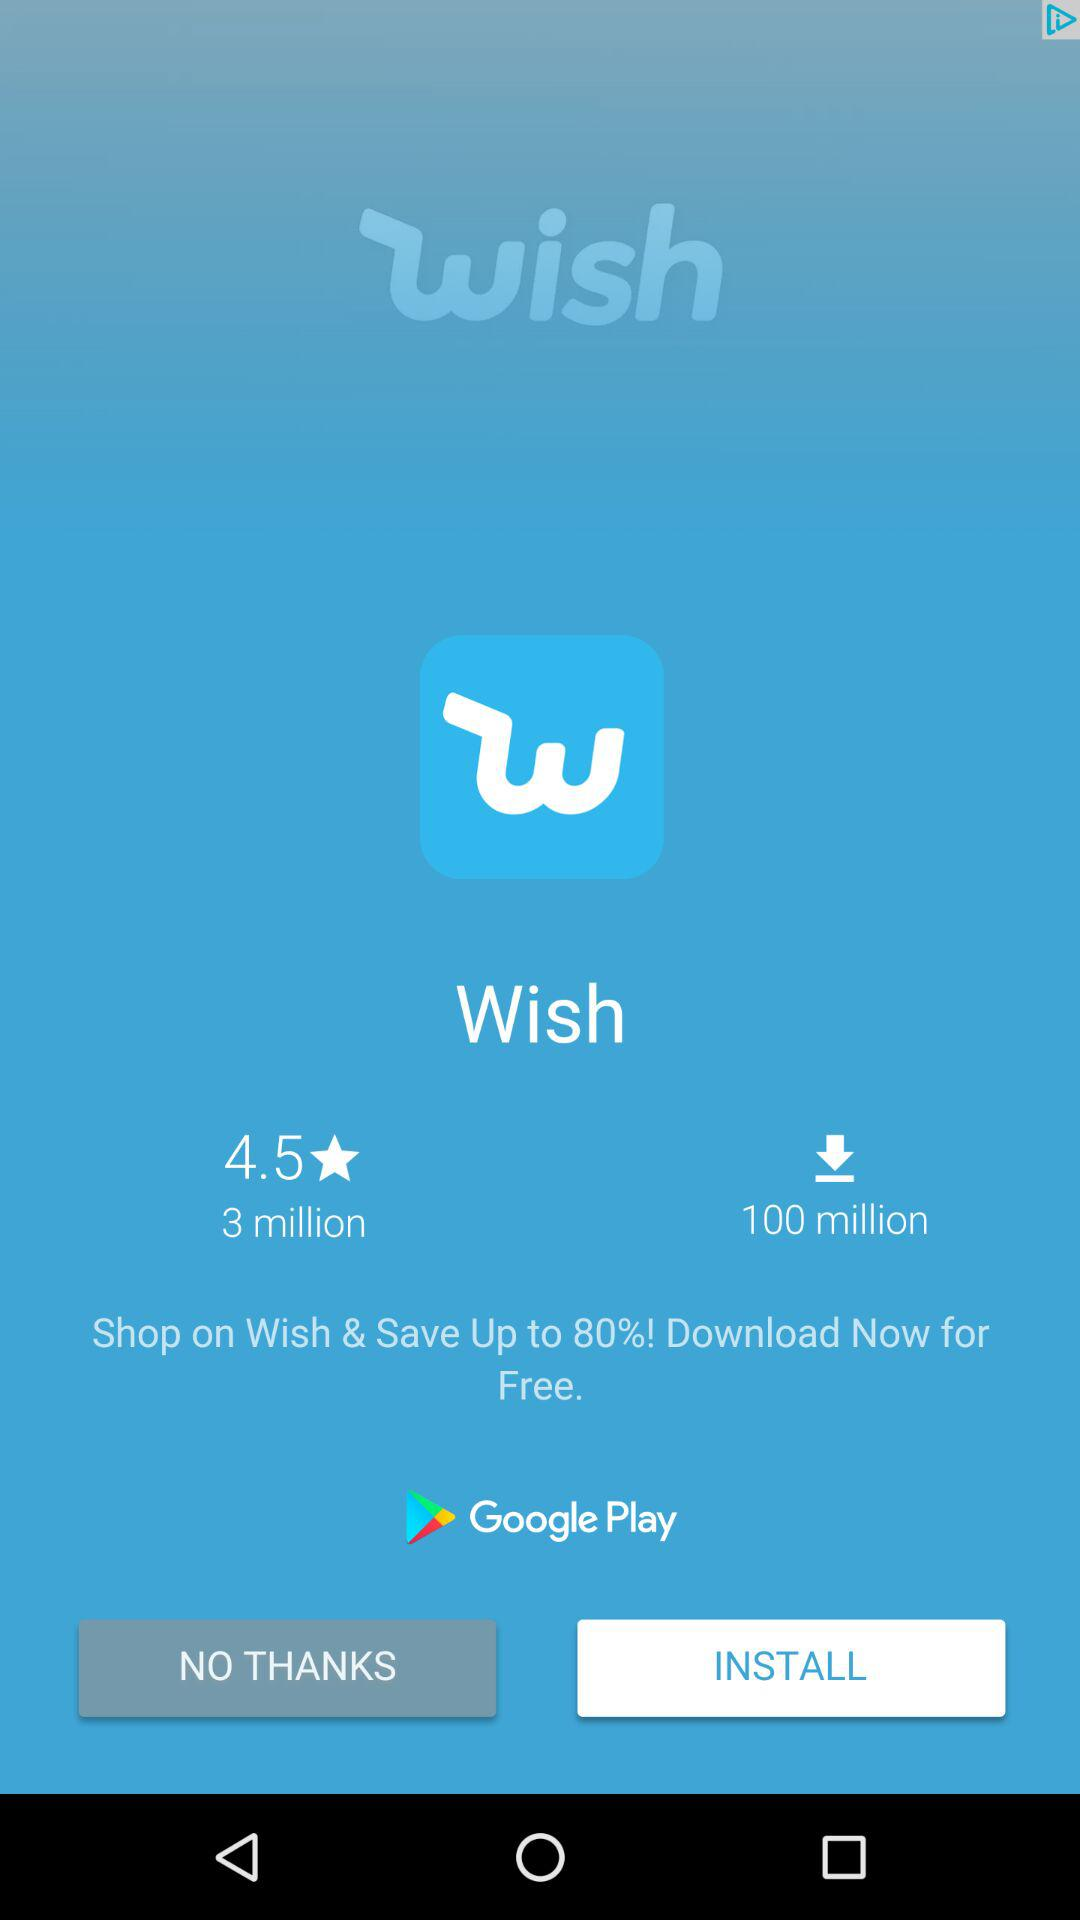How many more downloads does the app have than the number of people who have rated it?
Answer the question using a single word or phrase. 97 million 